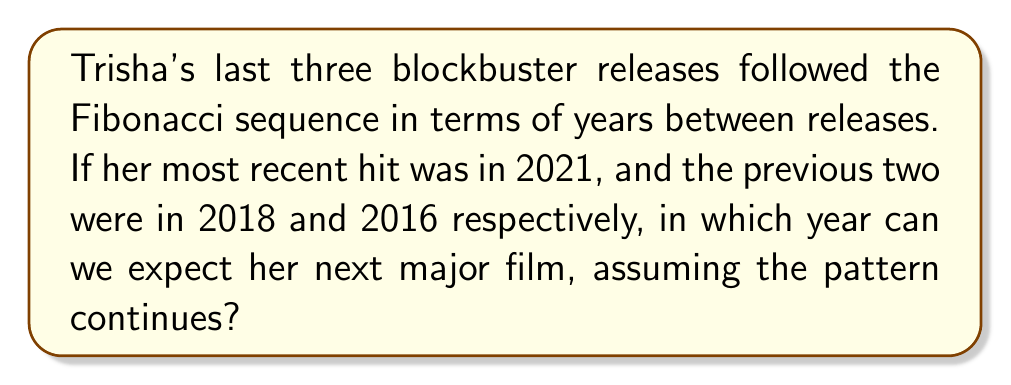Provide a solution to this math problem. Let's approach this step-by-step:

1) First, let's recall the Fibonacci sequence. Each number is the sum of the two preceding ones. The sequence starts: 0, 1, 1, 2, 3, 5, 8, 13, ...

2) Now, let's look at the years between Trisha's releases:
   2016 to 2018: 2 years
   2018 to 2021: 3 years

3) We can see that 2 and 3 are consecutive Fibonacci numbers.

4) If the pattern continues, the next number in the sequence would be 5, as:
   $$F_n = F_{n-1} + F_{n-2}$$
   $$5 = 3 + 2$$

5) Therefore, we expect 5 years to pass between the 2021 release and the next one.

6) To calculate the year of the next release:
   $$2021 + 5 = 2026$$

Thus, following the Fibonacci sequence pattern, Trisha's next major film release can be expected in 2026.
Answer: 2026 